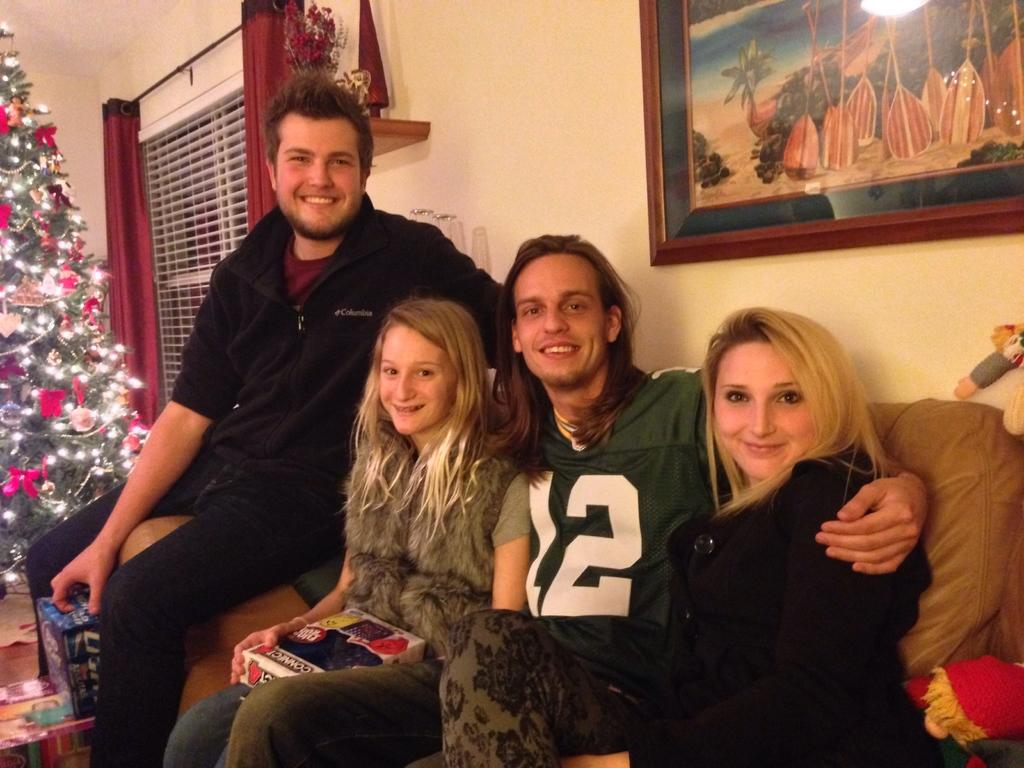What are the people in the image doing? There is a group of people sitting on the sofa. What can be seen on the left side of the image? There is a tree on the left side of the image. What is present on the wall in the background? There is a photo frame on the wall in the background. Can you hear the steam coming from the kettle in the image? There is no kettle or steam present in the image. What type of authority is depicted in the image? There is no authority figure present in the image. 